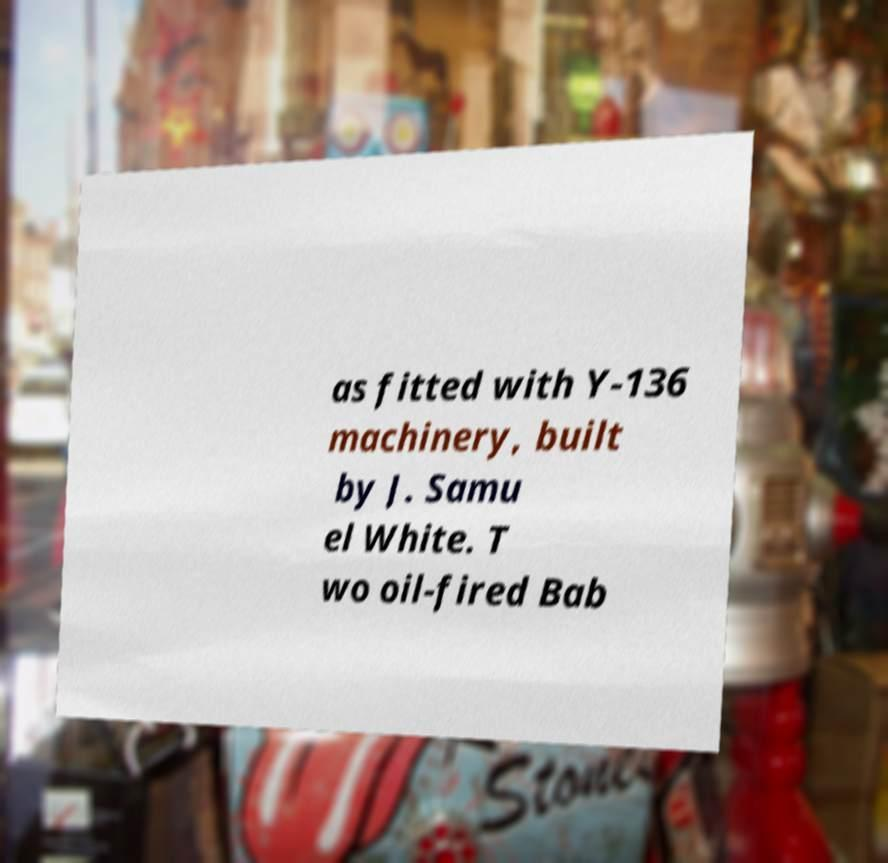Could you extract and type out the text from this image? as fitted with Y-136 machinery, built by J. Samu el White. T wo oil-fired Bab 